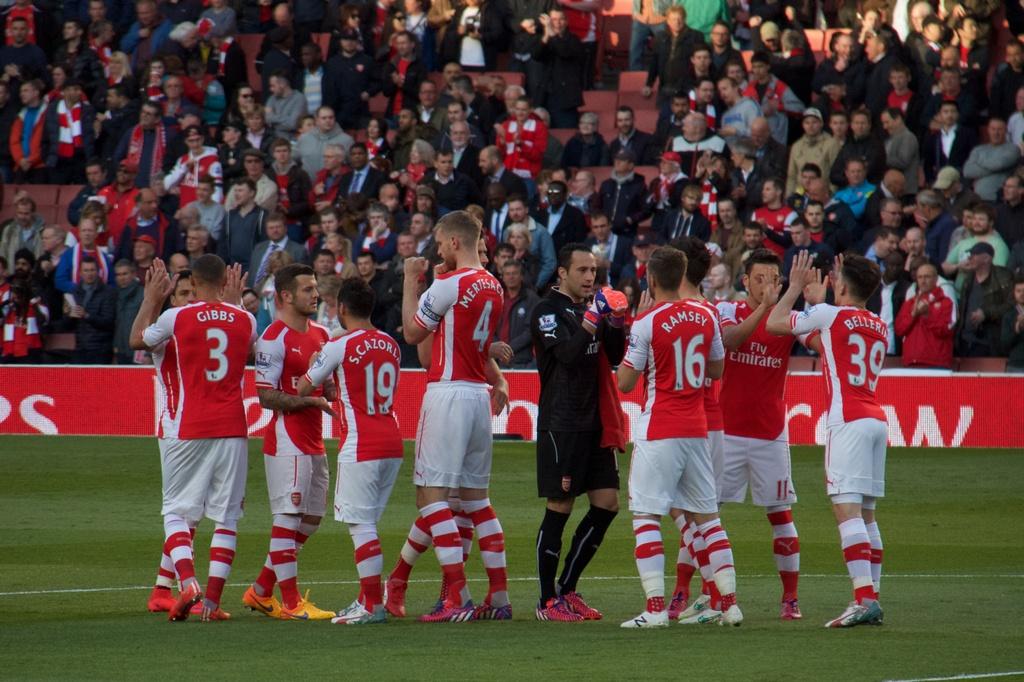What is the name of number 3?
Your answer should be compact. Gibbs. What number is ramsey?
Offer a very short reply. 16. 